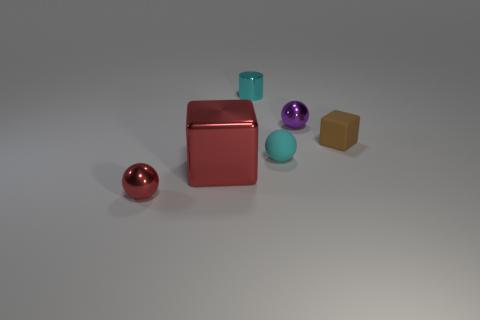Are there any green matte objects that have the same shape as the brown thing?
Your answer should be compact. No. There is a small ball that is the same color as the cylinder; what is its material?
Ensure brevity in your answer.  Rubber. What shape is the red metal thing that is behind the tiny metal sphere that is in front of the tiny purple metallic object?
Offer a terse response. Cube. What number of other red cylinders are the same material as the cylinder?
Ensure brevity in your answer.  0. There is a cylinder that is made of the same material as the red cube; what color is it?
Provide a short and direct response. Cyan. What is the size of the ball on the left side of the block that is to the left of the small metal thing on the right side of the cyan cylinder?
Keep it short and to the point. Small. Is the number of purple metal objects less than the number of tiny spheres?
Your response must be concise. Yes. The large thing that is the same shape as the tiny brown rubber thing is what color?
Give a very brief answer. Red. There is a tiny red metallic thing to the left of the small metal sphere behind the tiny matte sphere; are there any matte blocks in front of it?
Your response must be concise. No. Do the purple shiny thing and the tiny brown object have the same shape?
Provide a short and direct response. No. 